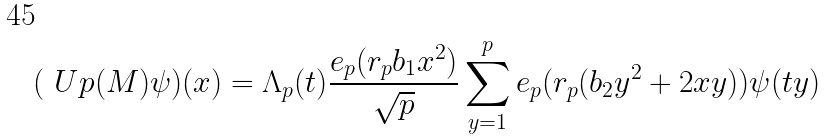Convert formula to latex. <formula><loc_0><loc_0><loc_500><loc_500>( \ U p ( M ) \psi ) ( x ) = \Lambda _ { p } ( t ) \frac { e _ { p } ( r _ { p } b _ { 1 } x ^ { 2 } ) } { \sqrt { p } } \sum _ { y = 1 } ^ { p } e _ { p } ( r _ { p } ( b _ { 2 } y ^ { 2 } + 2 x y ) ) \psi ( t y )</formula> 